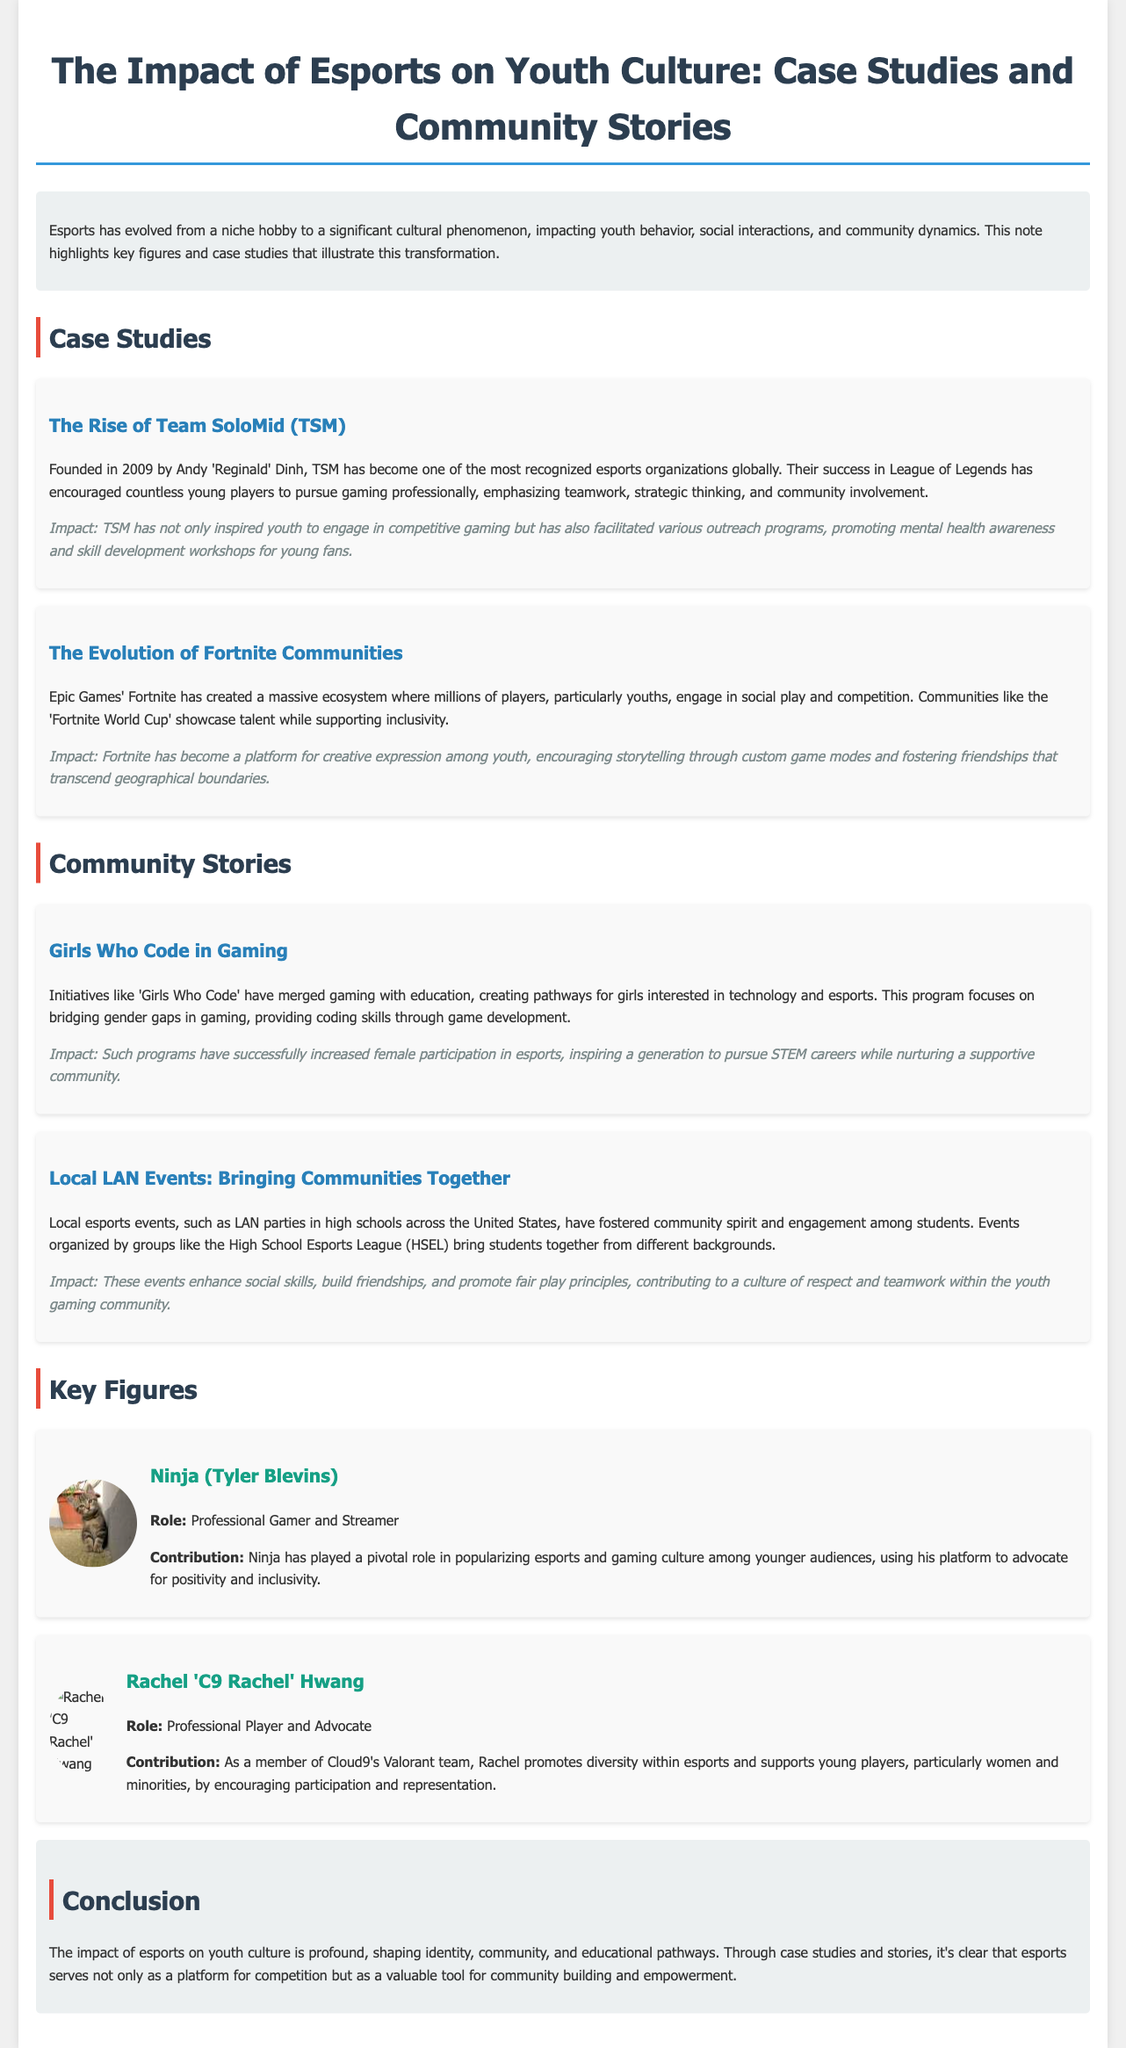What year was Team SoloMid (TSM) founded? The founding year of TSM is mentioned in the case study section of the document.
Answer: 2009 Who founded Team SoloMid (TSM)? The document provides the name of the founder of TSM in the case study section.
Answer: Andy 'Reginald' Dinh What is the main focus of the 'Girls Who Code' program? The document describes the objective of the 'Girls Who Code' program in the community story section.
Answer: Bridging gender gaps in gaming Which esports organization is Rachel 'C9 Rachel' Hwang a member of? The document states Rachel's affiliation in her key figure section.
Answer: Cloud9 What game has created a massive ecosystem for youth engagement according to the document? The community engagement mentioned in the case study is related to a specific game.
Answer: Fortnite How has TSM impacted youth beyond competitive gaming? The document explains TSM's impact on youth in terms of outreach programs in the case study.
Answer: Mental health awareness What type of events does the High School Esports League (HSEL) organize? The community story mentions the nature of events organized by HSEL.
Answer: Local esports events What is Ninja's role in the esports community? The document specifies Ninja's position and contribution in the key figure section.
Answer: Professional Gamer and Streamer 